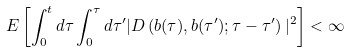<formula> <loc_0><loc_0><loc_500><loc_500>E \left [ \int _ { 0 } ^ { t } d \tau \int _ { 0 } ^ { \tau } d \tau ^ { \prime } | D \left ( { b } ( \tau ) , { b } ( \tau ^ { \prime } ) ; \tau - \tau ^ { \prime } \right ) | ^ { 2 } \right ] < \infty</formula> 